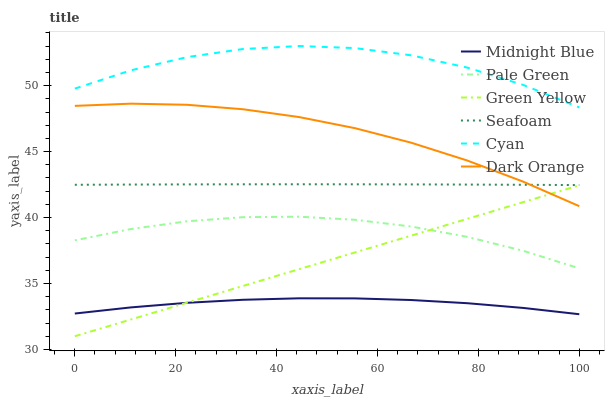Does Midnight Blue have the minimum area under the curve?
Answer yes or no. Yes. Does Cyan have the maximum area under the curve?
Answer yes or no. Yes. Does Seafoam have the minimum area under the curve?
Answer yes or no. No. Does Seafoam have the maximum area under the curve?
Answer yes or no. No. Is Green Yellow the smoothest?
Answer yes or no. Yes. Is Cyan the roughest?
Answer yes or no. Yes. Is Midnight Blue the smoothest?
Answer yes or no. No. Is Midnight Blue the roughest?
Answer yes or no. No. Does Green Yellow have the lowest value?
Answer yes or no. Yes. Does Midnight Blue have the lowest value?
Answer yes or no. No. Does Cyan have the highest value?
Answer yes or no. Yes. Does Seafoam have the highest value?
Answer yes or no. No. Is Pale Green less than Cyan?
Answer yes or no. Yes. Is Seafoam greater than Pale Green?
Answer yes or no. Yes. Does Seafoam intersect Dark Orange?
Answer yes or no. Yes. Is Seafoam less than Dark Orange?
Answer yes or no. No. Is Seafoam greater than Dark Orange?
Answer yes or no. No. Does Pale Green intersect Cyan?
Answer yes or no. No. 